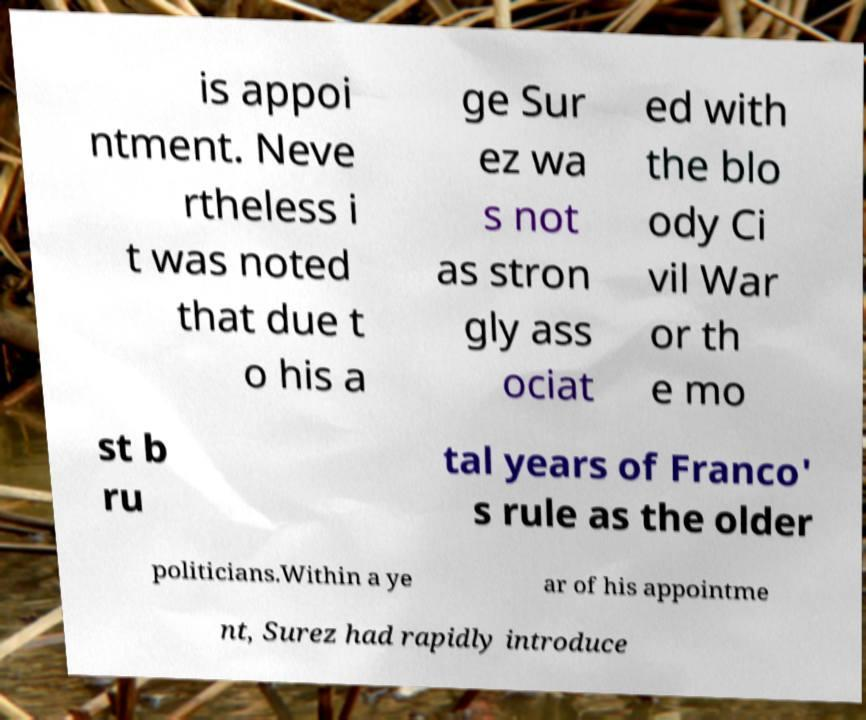Please read and relay the text visible in this image. What does it say? is appoi ntment. Neve rtheless i t was noted that due t o his a ge Sur ez wa s not as stron gly ass ociat ed with the blo ody Ci vil War or th e mo st b ru tal years of Franco' s rule as the older politicians.Within a ye ar of his appointme nt, Surez had rapidly introduce 